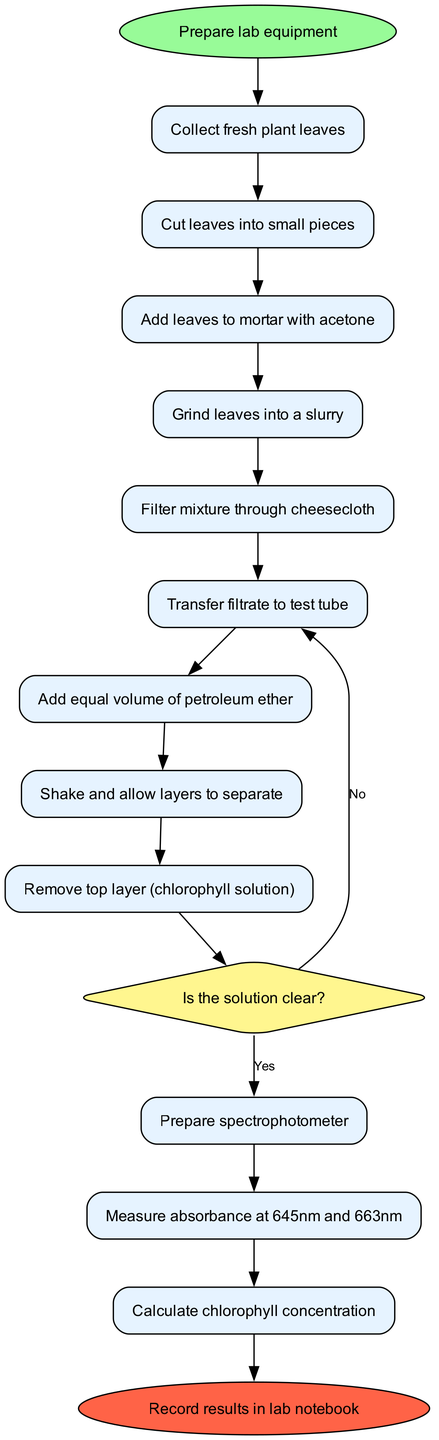What is the first activity in the workflow? The diagram starts with the node labeled "Prepare lab equipment". This indicates that it is the initial step the students must take before proceeding to the next activities.
Answer: Prepare lab equipment How many activities are listed in the diagram? The diagram contains 12 activities in total, including the starting activity. By counting all the activity nodes from "Collect fresh plant leaves" to "Calculate chlorophyll concentration", we reach a total of 12.
Answer: 12 What happens if the mixture solution is not clear? According to the decision node labeled "Is the solution clear?", if the solution is not clear, the workflow indicates to "Re-filter mixture". This shows that there is a process to follow if the desired clarity is not achieved.
Answer: Re-filter mixture What is the last action before recording results? The last action before reaching the end node "Record results in lab notebook" is "Calculate chlorophyll concentration". This indicates that the students must perform this calculation as the final step of the experiment.
Answer: Calculate chlorophyll concentration What question must be answered to proceed to the spectrophotometer? The question posed in the decision node is "Is the solution clear?". To move forward to the spectrophotometer, a "Yes" answer is required. This indicates the importance of ensuring solution clarity before taking further measurements.
Answer: Is the solution clear? After shaking, which layer is removed? The diagram specifies that after shaking and allowing the layers to separate, the top layer, which is the "chlorophyll solution", is to be removed. This defines a clear procedure in the extraction workflow.
Answer: Chlorophyll solution What is used to grind the leaves? The activity specifically states to "Grind leaves into a slurry" and that this should be done using a mortar with acetone. This highlights the materials and method for processing the plant leaves.
Answer: Mortar with acetone What type of diagram is this? The diagram represents an "Activity Diagram", which visually describes a flow of activities and decisions involved in a particular process—in this case, the student laboratory experiment workflow.
Answer: Activity Diagram 